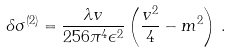Convert formula to latex. <formula><loc_0><loc_0><loc_500><loc_500>\delta \sigma ^ { ( 2 ) } = \frac { \lambda v } { 2 5 6 \pi ^ { 4 } \epsilon ^ { 2 } } \left ( \frac { v ^ { 2 } } { 4 } - m ^ { 2 } \right ) \, .</formula> 